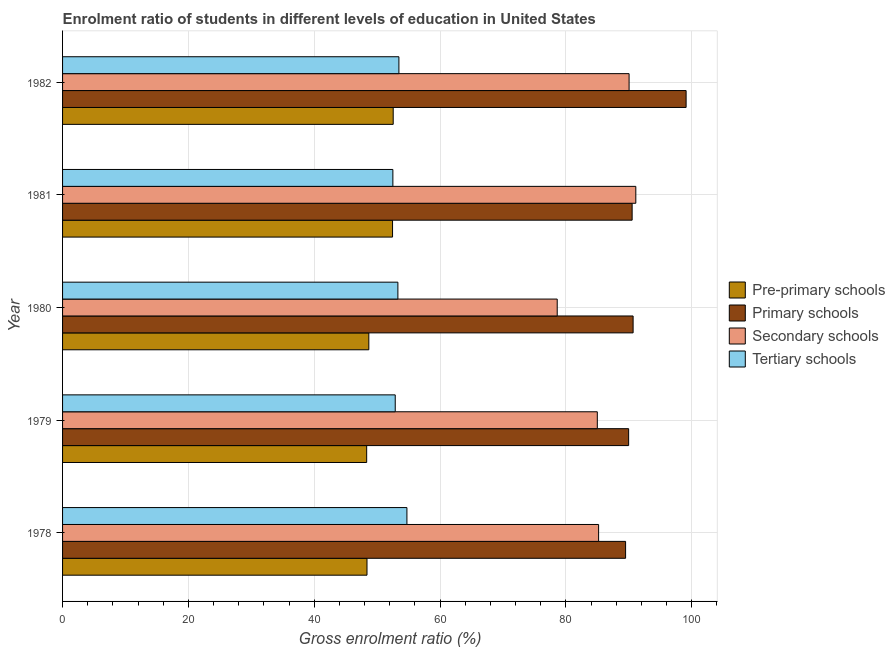How many different coloured bars are there?
Your response must be concise. 4. How many bars are there on the 3rd tick from the top?
Your answer should be very brief. 4. How many bars are there on the 4th tick from the bottom?
Your answer should be compact. 4. What is the label of the 4th group of bars from the top?
Keep it short and to the point. 1979. In how many cases, is the number of bars for a given year not equal to the number of legend labels?
Your answer should be compact. 0. What is the gross enrolment ratio in pre-primary schools in 1979?
Ensure brevity in your answer.  48.33. Across all years, what is the maximum gross enrolment ratio in tertiary schools?
Your answer should be compact. 54.73. Across all years, what is the minimum gross enrolment ratio in primary schools?
Give a very brief answer. 89.49. In which year was the gross enrolment ratio in primary schools minimum?
Your response must be concise. 1978. What is the total gross enrolment ratio in tertiary schools in the graph?
Ensure brevity in your answer.  266.86. What is the difference between the gross enrolment ratio in primary schools in 1978 and that in 1980?
Give a very brief answer. -1.19. What is the difference between the gross enrolment ratio in tertiary schools in 1982 and the gross enrolment ratio in primary schools in 1978?
Your answer should be compact. -36.03. What is the average gross enrolment ratio in pre-primary schools per year?
Give a very brief answer. 50.08. In the year 1978, what is the difference between the gross enrolment ratio in pre-primary schools and gross enrolment ratio in primary schools?
Your answer should be very brief. -41.1. What is the ratio of the gross enrolment ratio in secondary schools in 1978 to that in 1981?
Provide a short and direct response. 0.94. Is the gross enrolment ratio in tertiary schools in 1978 less than that in 1982?
Keep it short and to the point. No. What is the difference between the highest and the second highest gross enrolment ratio in primary schools?
Offer a very short reply. 8.42. What is the difference between the highest and the lowest gross enrolment ratio in tertiary schools?
Ensure brevity in your answer.  2.23. Is the sum of the gross enrolment ratio in tertiary schools in 1978 and 1982 greater than the maximum gross enrolment ratio in secondary schools across all years?
Your answer should be compact. Yes. Is it the case that in every year, the sum of the gross enrolment ratio in pre-primary schools and gross enrolment ratio in primary schools is greater than the sum of gross enrolment ratio in secondary schools and gross enrolment ratio in tertiary schools?
Provide a succinct answer. No. What does the 2nd bar from the top in 1980 represents?
Keep it short and to the point. Secondary schools. What does the 2nd bar from the bottom in 1979 represents?
Offer a very short reply. Primary schools. How many bars are there?
Your answer should be compact. 20. Are all the bars in the graph horizontal?
Give a very brief answer. Yes. How many years are there in the graph?
Your answer should be compact. 5. Are the values on the major ticks of X-axis written in scientific E-notation?
Provide a short and direct response. No. Does the graph contain any zero values?
Your response must be concise. No. Does the graph contain grids?
Provide a succinct answer. Yes. Where does the legend appear in the graph?
Ensure brevity in your answer.  Center right. How many legend labels are there?
Offer a very short reply. 4. How are the legend labels stacked?
Make the answer very short. Vertical. What is the title of the graph?
Your answer should be compact. Enrolment ratio of students in different levels of education in United States. Does "Compensation of employees" appear as one of the legend labels in the graph?
Provide a short and direct response. No. What is the Gross enrolment ratio (%) of Pre-primary schools in 1978?
Offer a very short reply. 48.39. What is the Gross enrolment ratio (%) in Primary schools in 1978?
Your answer should be compact. 89.49. What is the Gross enrolment ratio (%) of Secondary schools in 1978?
Give a very brief answer. 85.2. What is the Gross enrolment ratio (%) of Tertiary schools in 1978?
Make the answer very short. 54.73. What is the Gross enrolment ratio (%) of Pre-primary schools in 1979?
Provide a short and direct response. 48.33. What is the Gross enrolment ratio (%) of Primary schools in 1979?
Give a very brief answer. 89.97. What is the Gross enrolment ratio (%) of Secondary schools in 1979?
Ensure brevity in your answer.  84.99. What is the Gross enrolment ratio (%) of Tertiary schools in 1979?
Provide a short and direct response. 52.87. What is the Gross enrolment ratio (%) in Pre-primary schools in 1980?
Ensure brevity in your answer.  48.68. What is the Gross enrolment ratio (%) of Primary schools in 1980?
Make the answer very short. 90.68. What is the Gross enrolment ratio (%) in Secondary schools in 1980?
Provide a succinct answer. 78.62. What is the Gross enrolment ratio (%) of Tertiary schools in 1980?
Your answer should be compact. 53.3. What is the Gross enrolment ratio (%) of Pre-primary schools in 1981?
Make the answer very short. 52.45. What is the Gross enrolment ratio (%) of Primary schools in 1981?
Your response must be concise. 90.53. What is the Gross enrolment ratio (%) in Secondary schools in 1981?
Make the answer very short. 91.11. What is the Gross enrolment ratio (%) in Tertiary schools in 1981?
Provide a succinct answer. 52.5. What is the Gross enrolment ratio (%) in Pre-primary schools in 1982?
Offer a terse response. 52.55. What is the Gross enrolment ratio (%) in Primary schools in 1982?
Give a very brief answer. 99.11. What is the Gross enrolment ratio (%) in Secondary schools in 1982?
Provide a succinct answer. 90.04. What is the Gross enrolment ratio (%) in Tertiary schools in 1982?
Make the answer very short. 53.46. Across all years, what is the maximum Gross enrolment ratio (%) of Pre-primary schools?
Keep it short and to the point. 52.55. Across all years, what is the maximum Gross enrolment ratio (%) in Primary schools?
Give a very brief answer. 99.11. Across all years, what is the maximum Gross enrolment ratio (%) of Secondary schools?
Your answer should be compact. 91.11. Across all years, what is the maximum Gross enrolment ratio (%) of Tertiary schools?
Ensure brevity in your answer.  54.73. Across all years, what is the minimum Gross enrolment ratio (%) in Pre-primary schools?
Your response must be concise. 48.33. Across all years, what is the minimum Gross enrolment ratio (%) in Primary schools?
Keep it short and to the point. 89.49. Across all years, what is the minimum Gross enrolment ratio (%) in Secondary schools?
Your answer should be compact. 78.62. Across all years, what is the minimum Gross enrolment ratio (%) of Tertiary schools?
Your response must be concise. 52.5. What is the total Gross enrolment ratio (%) in Pre-primary schools in the graph?
Your response must be concise. 250.39. What is the total Gross enrolment ratio (%) of Primary schools in the graph?
Keep it short and to the point. 459.77. What is the total Gross enrolment ratio (%) of Secondary schools in the graph?
Your answer should be very brief. 429.96. What is the total Gross enrolment ratio (%) in Tertiary schools in the graph?
Keep it short and to the point. 266.86. What is the difference between the Gross enrolment ratio (%) of Pre-primary schools in 1978 and that in 1979?
Ensure brevity in your answer.  0.05. What is the difference between the Gross enrolment ratio (%) in Primary schools in 1978 and that in 1979?
Your answer should be compact. -0.48. What is the difference between the Gross enrolment ratio (%) of Secondary schools in 1978 and that in 1979?
Your response must be concise. 0.21. What is the difference between the Gross enrolment ratio (%) of Tertiary schools in 1978 and that in 1979?
Your answer should be very brief. 1.86. What is the difference between the Gross enrolment ratio (%) of Pre-primary schools in 1978 and that in 1980?
Give a very brief answer. -0.29. What is the difference between the Gross enrolment ratio (%) of Primary schools in 1978 and that in 1980?
Ensure brevity in your answer.  -1.19. What is the difference between the Gross enrolment ratio (%) of Secondary schools in 1978 and that in 1980?
Your response must be concise. 6.58. What is the difference between the Gross enrolment ratio (%) in Tertiary schools in 1978 and that in 1980?
Your response must be concise. 1.43. What is the difference between the Gross enrolment ratio (%) of Pre-primary schools in 1978 and that in 1981?
Give a very brief answer. -4.06. What is the difference between the Gross enrolment ratio (%) in Primary schools in 1978 and that in 1981?
Make the answer very short. -1.04. What is the difference between the Gross enrolment ratio (%) in Secondary schools in 1978 and that in 1981?
Make the answer very short. -5.91. What is the difference between the Gross enrolment ratio (%) in Tertiary schools in 1978 and that in 1981?
Make the answer very short. 2.23. What is the difference between the Gross enrolment ratio (%) in Pre-primary schools in 1978 and that in 1982?
Your answer should be very brief. -4.16. What is the difference between the Gross enrolment ratio (%) of Primary schools in 1978 and that in 1982?
Provide a short and direct response. -9.62. What is the difference between the Gross enrolment ratio (%) of Secondary schools in 1978 and that in 1982?
Give a very brief answer. -4.84. What is the difference between the Gross enrolment ratio (%) in Tertiary schools in 1978 and that in 1982?
Offer a very short reply. 1.27. What is the difference between the Gross enrolment ratio (%) of Pre-primary schools in 1979 and that in 1980?
Offer a terse response. -0.34. What is the difference between the Gross enrolment ratio (%) in Primary schools in 1979 and that in 1980?
Give a very brief answer. -0.71. What is the difference between the Gross enrolment ratio (%) in Secondary schools in 1979 and that in 1980?
Offer a terse response. 6.37. What is the difference between the Gross enrolment ratio (%) in Tertiary schools in 1979 and that in 1980?
Ensure brevity in your answer.  -0.42. What is the difference between the Gross enrolment ratio (%) in Pre-primary schools in 1979 and that in 1981?
Keep it short and to the point. -4.11. What is the difference between the Gross enrolment ratio (%) of Primary schools in 1979 and that in 1981?
Offer a terse response. -0.56. What is the difference between the Gross enrolment ratio (%) of Secondary schools in 1979 and that in 1981?
Provide a short and direct response. -6.12. What is the difference between the Gross enrolment ratio (%) of Tertiary schools in 1979 and that in 1981?
Your answer should be compact. 0.38. What is the difference between the Gross enrolment ratio (%) of Pre-primary schools in 1979 and that in 1982?
Keep it short and to the point. -4.22. What is the difference between the Gross enrolment ratio (%) of Primary schools in 1979 and that in 1982?
Give a very brief answer. -9.13. What is the difference between the Gross enrolment ratio (%) of Secondary schools in 1979 and that in 1982?
Your answer should be very brief. -5.05. What is the difference between the Gross enrolment ratio (%) in Tertiary schools in 1979 and that in 1982?
Make the answer very short. -0.58. What is the difference between the Gross enrolment ratio (%) in Pre-primary schools in 1980 and that in 1981?
Provide a short and direct response. -3.77. What is the difference between the Gross enrolment ratio (%) of Primary schools in 1980 and that in 1981?
Offer a very short reply. 0.16. What is the difference between the Gross enrolment ratio (%) of Secondary schools in 1980 and that in 1981?
Your answer should be very brief. -12.49. What is the difference between the Gross enrolment ratio (%) of Tertiary schools in 1980 and that in 1981?
Your answer should be compact. 0.8. What is the difference between the Gross enrolment ratio (%) in Pre-primary schools in 1980 and that in 1982?
Keep it short and to the point. -3.87. What is the difference between the Gross enrolment ratio (%) of Primary schools in 1980 and that in 1982?
Your response must be concise. -8.42. What is the difference between the Gross enrolment ratio (%) in Secondary schools in 1980 and that in 1982?
Your response must be concise. -11.42. What is the difference between the Gross enrolment ratio (%) of Tertiary schools in 1980 and that in 1982?
Keep it short and to the point. -0.16. What is the difference between the Gross enrolment ratio (%) in Pre-primary schools in 1981 and that in 1982?
Your response must be concise. -0.1. What is the difference between the Gross enrolment ratio (%) of Primary schools in 1981 and that in 1982?
Provide a succinct answer. -8.58. What is the difference between the Gross enrolment ratio (%) in Secondary schools in 1981 and that in 1982?
Make the answer very short. 1.07. What is the difference between the Gross enrolment ratio (%) in Tertiary schools in 1981 and that in 1982?
Provide a short and direct response. -0.96. What is the difference between the Gross enrolment ratio (%) in Pre-primary schools in 1978 and the Gross enrolment ratio (%) in Primary schools in 1979?
Your answer should be very brief. -41.58. What is the difference between the Gross enrolment ratio (%) of Pre-primary schools in 1978 and the Gross enrolment ratio (%) of Secondary schools in 1979?
Your answer should be compact. -36.6. What is the difference between the Gross enrolment ratio (%) of Pre-primary schools in 1978 and the Gross enrolment ratio (%) of Tertiary schools in 1979?
Your answer should be very brief. -4.49. What is the difference between the Gross enrolment ratio (%) in Primary schools in 1978 and the Gross enrolment ratio (%) in Secondary schools in 1979?
Give a very brief answer. 4.5. What is the difference between the Gross enrolment ratio (%) of Primary schools in 1978 and the Gross enrolment ratio (%) of Tertiary schools in 1979?
Offer a terse response. 36.61. What is the difference between the Gross enrolment ratio (%) of Secondary schools in 1978 and the Gross enrolment ratio (%) of Tertiary schools in 1979?
Your response must be concise. 32.32. What is the difference between the Gross enrolment ratio (%) of Pre-primary schools in 1978 and the Gross enrolment ratio (%) of Primary schools in 1980?
Keep it short and to the point. -42.3. What is the difference between the Gross enrolment ratio (%) in Pre-primary schools in 1978 and the Gross enrolment ratio (%) in Secondary schools in 1980?
Offer a terse response. -30.23. What is the difference between the Gross enrolment ratio (%) of Pre-primary schools in 1978 and the Gross enrolment ratio (%) of Tertiary schools in 1980?
Ensure brevity in your answer.  -4.91. What is the difference between the Gross enrolment ratio (%) of Primary schools in 1978 and the Gross enrolment ratio (%) of Secondary schools in 1980?
Offer a terse response. 10.87. What is the difference between the Gross enrolment ratio (%) in Primary schools in 1978 and the Gross enrolment ratio (%) in Tertiary schools in 1980?
Your answer should be very brief. 36.19. What is the difference between the Gross enrolment ratio (%) in Secondary schools in 1978 and the Gross enrolment ratio (%) in Tertiary schools in 1980?
Your answer should be very brief. 31.9. What is the difference between the Gross enrolment ratio (%) in Pre-primary schools in 1978 and the Gross enrolment ratio (%) in Primary schools in 1981?
Your answer should be compact. -42.14. What is the difference between the Gross enrolment ratio (%) in Pre-primary schools in 1978 and the Gross enrolment ratio (%) in Secondary schools in 1981?
Your response must be concise. -42.73. What is the difference between the Gross enrolment ratio (%) in Pre-primary schools in 1978 and the Gross enrolment ratio (%) in Tertiary schools in 1981?
Your response must be concise. -4.11. What is the difference between the Gross enrolment ratio (%) in Primary schools in 1978 and the Gross enrolment ratio (%) in Secondary schools in 1981?
Give a very brief answer. -1.62. What is the difference between the Gross enrolment ratio (%) in Primary schools in 1978 and the Gross enrolment ratio (%) in Tertiary schools in 1981?
Your answer should be compact. 36.99. What is the difference between the Gross enrolment ratio (%) in Secondary schools in 1978 and the Gross enrolment ratio (%) in Tertiary schools in 1981?
Your answer should be very brief. 32.7. What is the difference between the Gross enrolment ratio (%) of Pre-primary schools in 1978 and the Gross enrolment ratio (%) of Primary schools in 1982?
Offer a very short reply. -50.72. What is the difference between the Gross enrolment ratio (%) of Pre-primary schools in 1978 and the Gross enrolment ratio (%) of Secondary schools in 1982?
Provide a short and direct response. -41.66. What is the difference between the Gross enrolment ratio (%) in Pre-primary schools in 1978 and the Gross enrolment ratio (%) in Tertiary schools in 1982?
Your answer should be very brief. -5.07. What is the difference between the Gross enrolment ratio (%) of Primary schools in 1978 and the Gross enrolment ratio (%) of Secondary schools in 1982?
Keep it short and to the point. -0.55. What is the difference between the Gross enrolment ratio (%) of Primary schools in 1978 and the Gross enrolment ratio (%) of Tertiary schools in 1982?
Give a very brief answer. 36.03. What is the difference between the Gross enrolment ratio (%) of Secondary schools in 1978 and the Gross enrolment ratio (%) of Tertiary schools in 1982?
Provide a short and direct response. 31.74. What is the difference between the Gross enrolment ratio (%) of Pre-primary schools in 1979 and the Gross enrolment ratio (%) of Primary schools in 1980?
Offer a terse response. -42.35. What is the difference between the Gross enrolment ratio (%) of Pre-primary schools in 1979 and the Gross enrolment ratio (%) of Secondary schools in 1980?
Provide a short and direct response. -30.29. What is the difference between the Gross enrolment ratio (%) of Pre-primary schools in 1979 and the Gross enrolment ratio (%) of Tertiary schools in 1980?
Your response must be concise. -4.96. What is the difference between the Gross enrolment ratio (%) in Primary schools in 1979 and the Gross enrolment ratio (%) in Secondary schools in 1980?
Make the answer very short. 11.35. What is the difference between the Gross enrolment ratio (%) of Primary schools in 1979 and the Gross enrolment ratio (%) of Tertiary schools in 1980?
Keep it short and to the point. 36.67. What is the difference between the Gross enrolment ratio (%) of Secondary schools in 1979 and the Gross enrolment ratio (%) of Tertiary schools in 1980?
Keep it short and to the point. 31.69. What is the difference between the Gross enrolment ratio (%) of Pre-primary schools in 1979 and the Gross enrolment ratio (%) of Primary schools in 1981?
Your answer should be compact. -42.19. What is the difference between the Gross enrolment ratio (%) of Pre-primary schools in 1979 and the Gross enrolment ratio (%) of Secondary schools in 1981?
Ensure brevity in your answer.  -42.78. What is the difference between the Gross enrolment ratio (%) of Pre-primary schools in 1979 and the Gross enrolment ratio (%) of Tertiary schools in 1981?
Ensure brevity in your answer.  -4.17. What is the difference between the Gross enrolment ratio (%) of Primary schools in 1979 and the Gross enrolment ratio (%) of Secondary schools in 1981?
Provide a short and direct response. -1.14. What is the difference between the Gross enrolment ratio (%) in Primary schools in 1979 and the Gross enrolment ratio (%) in Tertiary schools in 1981?
Make the answer very short. 37.47. What is the difference between the Gross enrolment ratio (%) of Secondary schools in 1979 and the Gross enrolment ratio (%) of Tertiary schools in 1981?
Offer a very short reply. 32.49. What is the difference between the Gross enrolment ratio (%) in Pre-primary schools in 1979 and the Gross enrolment ratio (%) in Primary schools in 1982?
Ensure brevity in your answer.  -50.77. What is the difference between the Gross enrolment ratio (%) of Pre-primary schools in 1979 and the Gross enrolment ratio (%) of Secondary schools in 1982?
Give a very brief answer. -41.71. What is the difference between the Gross enrolment ratio (%) in Pre-primary schools in 1979 and the Gross enrolment ratio (%) in Tertiary schools in 1982?
Your answer should be very brief. -5.12. What is the difference between the Gross enrolment ratio (%) of Primary schools in 1979 and the Gross enrolment ratio (%) of Secondary schools in 1982?
Make the answer very short. -0.07. What is the difference between the Gross enrolment ratio (%) in Primary schools in 1979 and the Gross enrolment ratio (%) in Tertiary schools in 1982?
Give a very brief answer. 36.51. What is the difference between the Gross enrolment ratio (%) of Secondary schools in 1979 and the Gross enrolment ratio (%) of Tertiary schools in 1982?
Offer a very short reply. 31.53. What is the difference between the Gross enrolment ratio (%) of Pre-primary schools in 1980 and the Gross enrolment ratio (%) of Primary schools in 1981?
Provide a succinct answer. -41.85. What is the difference between the Gross enrolment ratio (%) of Pre-primary schools in 1980 and the Gross enrolment ratio (%) of Secondary schools in 1981?
Offer a very short reply. -42.44. What is the difference between the Gross enrolment ratio (%) in Pre-primary schools in 1980 and the Gross enrolment ratio (%) in Tertiary schools in 1981?
Your answer should be very brief. -3.82. What is the difference between the Gross enrolment ratio (%) of Primary schools in 1980 and the Gross enrolment ratio (%) of Secondary schools in 1981?
Your response must be concise. -0.43. What is the difference between the Gross enrolment ratio (%) of Primary schools in 1980 and the Gross enrolment ratio (%) of Tertiary schools in 1981?
Your answer should be compact. 38.18. What is the difference between the Gross enrolment ratio (%) of Secondary schools in 1980 and the Gross enrolment ratio (%) of Tertiary schools in 1981?
Make the answer very short. 26.12. What is the difference between the Gross enrolment ratio (%) of Pre-primary schools in 1980 and the Gross enrolment ratio (%) of Primary schools in 1982?
Make the answer very short. -50.43. What is the difference between the Gross enrolment ratio (%) in Pre-primary schools in 1980 and the Gross enrolment ratio (%) in Secondary schools in 1982?
Provide a succinct answer. -41.37. What is the difference between the Gross enrolment ratio (%) in Pre-primary schools in 1980 and the Gross enrolment ratio (%) in Tertiary schools in 1982?
Offer a terse response. -4.78. What is the difference between the Gross enrolment ratio (%) of Primary schools in 1980 and the Gross enrolment ratio (%) of Secondary schools in 1982?
Provide a short and direct response. 0.64. What is the difference between the Gross enrolment ratio (%) of Primary schools in 1980 and the Gross enrolment ratio (%) of Tertiary schools in 1982?
Offer a very short reply. 37.22. What is the difference between the Gross enrolment ratio (%) of Secondary schools in 1980 and the Gross enrolment ratio (%) of Tertiary schools in 1982?
Your response must be concise. 25.16. What is the difference between the Gross enrolment ratio (%) in Pre-primary schools in 1981 and the Gross enrolment ratio (%) in Primary schools in 1982?
Offer a terse response. -46.66. What is the difference between the Gross enrolment ratio (%) of Pre-primary schools in 1981 and the Gross enrolment ratio (%) of Secondary schools in 1982?
Keep it short and to the point. -37.6. What is the difference between the Gross enrolment ratio (%) of Pre-primary schools in 1981 and the Gross enrolment ratio (%) of Tertiary schools in 1982?
Keep it short and to the point. -1.01. What is the difference between the Gross enrolment ratio (%) of Primary schools in 1981 and the Gross enrolment ratio (%) of Secondary schools in 1982?
Provide a short and direct response. 0.48. What is the difference between the Gross enrolment ratio (%) of Primary schools in 1981 and the Gross enrolment ratio (%) of Tertiary schools in 1982?
Offer a terse response. 37.07. What is the difference between the Gross enrolment ratio (%) in Secondary schools in 1981 and the Gross enrolment ratio (%) in Tertiary schools in 1982?
Make the answer very short. 37.65. What is the average Gross enrolment ratio (%) in Pre-primary schools per year?
Provide a short and direct response. 50.08. What is the average Gross enrolment ratio (%) in Primary schools per year?
Your answer should be very brief. 91.95. What is the average Gross enrolment ratio (%) of Secondary schools per year?
Ensure brevity in your answer.  85.99. What is the average Gross enrolment ratio (%) of Tertiary schools per year?
Provide a succinct answer. 53.37. In the year 1978, what is the difference between the Gross enrolment ratio (%) in Pre-primary schools and Gross enrolment ratio (%) in Primary schools?
Make the answer very short. -41.1. In the year 1978, what is the difference between the Gross enrolment ratio (%) of Pre-primary schools and Gross enrolment ratio (%) of Secondary schools?
Give a very brief answer. -36.81. In the year 1978, what is the difference between the Gross enrolment ratio (%) in Pre-primary schools and Gross enrolment ratio (%) in Tertiary schools?
Offer a very short reply. -6.34. In the year 1978, what is the difference between the Gross enrolment ratio (%) in Primary schools and Gross enrolment ratio (%) in Secondary schools?
Ensure brevity in your answer.  4.29. In the year 1978, what is the difference between the Gross enrolment ratio (%) of Primary schools and Gross enrolment ratio (%) of Tertiary schools?
Provide a short and direct response. 34.76. In the year 1978, what is the difference between the Gross enrolment ratio (%) in Secondary schools and Gross enrolment ratio (%) in Tertiary schools?
Your answer should be compact. 30.47. In the year 1979, what is the difference between the Gross enrolment ratio (%) in Pre-primary schools and Gross enrolment ratio (%) in Primary schools?
Give a very brief answer. -41.64. In the year 1979, what is the difference between the Gross enrolment ratio (%) in Pre-primary schools and Gross enrolment ratio (%) in Secondary schools?
Provide a short and direct response. -36.66. In the year 1979, what is the difference between the Gross enrolment ratio (%) in Pre-primary schools and Gross enrolment ratio (%) in Tertiary schools?
Your response must be concise. -4.54. In the year 1979, what is the difference between the Gross enrolment ratio (%) in Primary schools and Gross enrolment ratio (%) in Secondary schools?
Offer a terse response. 4.98. In the year 1979, what is the difference between the Gross enrolment ratio (%) of Primary schools and Gross enrolment ratio (%) of Tertiary schools?
Make the answer very short. 37.1. In the year 1979, what is the difference between the Gross enrolment ratio (%) of Secondary schools and Gross enrolment ratio (%) of Tertiary schools?
Make the answer very short. 32.12. In the year 1980, what is the difference between the Gross enrolment ratio (%) in Pre-primary schools and Gross enrolment ratio (%) in Primary schools?
Make the answer very short. -42.01. In the year 1980, what is the difference between the Gross enrolment ratio (%) of Pre-primary schools and Gross enrolment ratio (%) of Secondary schools?
Offer a terse response. -29.94. In the year 1980, what is the difference between the Gross enrolment ratio (%) of Pre-primary schools and Gross enrolment ratio (%) of Tertiary schools?
Provide a succinct answer. -4.62. In the year 1980, what is the difference between the Gross enrolment ratio (%) of Primary schools and Gross enrolment ratio (%) of Secondary schools?
Give a very brief answer. 12.06. In the year 1980, what is the difference between the Gross enrolment ratio (%) in Primary schools and Gross enrolment ratio (%) in Tertiary schools?
Provide a short and direct response. 37.39. In the year 1980, what is the difference between the Gross enrolment ratio (%) in Secondary schools and Gross enrolment ratio (%) in Tertiary schools?
Keep it short and to the point. 25.32. In the year 1981, what is the difference between the Gross enrolment ratio (%) of Pre-primary schools and Gross enrolment ratio (%) of Primary schools?
Offer a very short reply. -38.08. In the year 1981, what is the difference between the Gross enrolment ratio (%) in Pre-primary schools and Gross enrolment ratio (%) in Secondary schools?
Your answer should be compact. -38.67. In the year 1981, what is the difference between the Gross enrolment ratio (%) of Pre-primary schools and Gross enrolment ratio (%) of Tertiary schools?
Offer a terse response. -0.05. In the year 1981, what is the difference between the Gross enrolment ratio (%) of Primary schools and Gross enrolment ratio (%) of Secondary schools?
Keep it short and to the point. -0.59. In the year 1981, what is the difference between the Gross enrolment ratio (%) in Primary schools and Gross enrolment ratio (%) in Tertiary schools?
Provide a succinct answer. 38.03. In the year 1981, what is the difference between the Gross enrolment ratio (%) in Secondary schools and Gross enrolment ratio (%) in Tertiary schools?
Your answer should be compact. 38.61. In the year 1982, what is the difference between the Gross enrolment ratio (%) in Pre-primary schools and Gross enrolment ratio (%) in Primary schools?
Your answer should be very brief. -46.55. In the year 1982, what is the difference between the Gross enrolment ratio (%) in Pre-primary schools and Gross enrolment ratio (%) in Secondary schools?
Make the answer very short. -37.49. In the year 1982, what is the difference between the Gross enrolment ratio (%) of Pre-primary schools and Gross enrolment ratio (%) of Tertiary schools?
Your answer should be compact. -0.91. In the year 1982, what is the difference between the Gross enrolment ratio (%) of Primary schools and Gross enrolment ratio (%) of Secondary schools?
Ensure brevity in your answer.  9.06. In the year 1982, what is the difference between the Gross enrolment ratio (%) of Primary schools and Gross enrolment ratio (%) of Tertiary schools?
Make the answer very short. 45.65. In the year 1982, what is the difference between the Gross enrolment ratio (%) in Secondary schools and Gross enrolment ratio (%) in Tertiary schools?
Your answer should be very brief. 36.58. What is the ratio of the Gross enrolment ratio (%) in Pre-primary schools in 1978 to that in 1979?
Your response must be concise. 1. What is the ratio of the Gross enrolment ratio (%) of Secondary schools in 1978 to that in 1979?
Keep it short and to the point. 1. What is the ratio of the Gross enrolment ratio (%) in Tertiary schools in 1978 to that in 1979?
Ensure brevity in your answer.  1.04. What is the ratio of the Gross enrolment ratio (%) of Primary schools in 1978 to that in 1980?
Make the answer very short. 0.99. What is the ratio of the Gross enrolment ratio (%) in Secondary schools in 1978 to that in 1980?
Provide a succinct answer. 1.08. What is the ratio of the Gross enrolment ratio (%) of Tertiary schools in 1978 to that in 1980?
Provide a succinct answer. 1.03. What is the ratio of the Gross enrolment ratio (%) of Pre-primary schools in 1978 to that in 1981?
Your answer should be very brief. 0.92. What is the ratio of the Gross enrolment ratio (%) of Secondary schools in 1978 to that in 1981?
Offer a very short reply. 0.94. What is the ratio of the Gross enrolment ratio (%) of Tertiary schools in 1978 to that in 1981?
Your answer should be compact. 1.04. What is the ratio of the Gross enrolment ratio (%) of Pre-primary schools in 1978 to that in 1982?
Your response must be concise. 0.92. What is the ratio of the Gross enrolment ratio (%) in Primary schools in 1978 to that in 1982?
Make the answer very short. 0.9. What is the ratio of the Gross enrolment ratio (%) in Secondary schools in 1978 to that in 1982?
Offer a terse response. 0.95. What is the ratio of the Gross enrolment ratio (%) in Tertiary schools in 1978 to that in 1982?
Make the answer very short. 1.02. What is the ratio of the Gross enrolment ratio (%) of Pre-primary schools in 1979 to that in 1980?
Provide a succinct answer. 0.99. What is the ratio of the Gross enrolment ratio (%) in Secondary schools in 1979 to that in 1980?
Your answer should be compact. 1.08. What is the ratio of the Gross enrolment ratio (%) in Tertiary schools in 1979 to that in 1980?
Your answer should be compact. 0.99. What is the ratio of the Gross enrolment ratio (%) in Pre-primary schools in 1979 to that in 1981?
Your answer should be very brief. 0.92. What is the ratio of the Gross enrolment ratio (%) of Secondary schools in 1979 to that in 1981?
Give a very brief answer. 0.93. What is the ratio of the Gross enrolment ratio (%) in Tertiary schools in 1979 to that in 1981?
Offer a very short reply. 1.01. What is the ratio of the Gross enrolment ratio (%) in Pre-primary schools in 1979 to that in 1982?
Ensure brevity in your answer.  0.92. What is the ratio of the Gross enrolment ratio (%) of Primary schools in 1979 to that in 1982?
Offer a very short reply. 0.91. What is the ratio of the Gross enrolment ratio (%) in Secondary schools in 1979 to that in 1982?
Your response must be concise. 0.94. What is the ratio of the Gross enrolment ratio (%) in Tertiary schools in 1979 to that in 1982?
Make the answer very short. 0.99. What is the ratio of the Gross enrolment ratio (%) in Pre-primary schools in 1980 to that in 1981?
Your answer should be very brief. 0.93. What is the ratio of the Gross enrolment ratio (%) in Primary schools in 1980 to that in 1981?
Ensure brevity in your answer.  1. What is the ratio of the Gross enrolment ratio (%) in Secondary schools in 1980 to that in 1981?
Ensure brevity in your answer.  0.86. What is the ratio of the Gross enrolment ratio (%) in Tertiary schools in 1980 to that in 1981?
Your answer should be compact. 1.02. What is the ratio of the Gross enrolment ratio (%) in Pre-primary schools in 1980 to that in 1982?
Your response must be concise. 0.93. What is the ratio of the Gross enrolment ratio (%) of Primary schools in 1980 to that in 1982?
Your answer should be compact. 0.92. What is the ratio of the Gross enrolment ratio (%) of Secondary schools in 1980 to that in 1982?
Provide a short and direct response. 0.87. What is the ratio of the Gross enrolment ratio (%) in Primary schools in 1981 to that in 1982?
Make the answer very short. 0.91. What is the ratio of the Gross enrolment ratio (%) of Secondary schools in 1981 to that in 1982?
Make the answer very short. 1.01. What is the ratio of the Gross enrolment ratio (%) of Tertiary schools in 1981 to that in 1982?
Offer a terse response. 0.98. What is the difference between the highest and the second highest Gross enrolment ratio (%) of Pre-primary schools?
Provide a succinct answer. 0.1. What is the difference between the highest and the second highest Gross enrolment ratio (%) of Primary schools?
Ensure brevity in your answer.  8.42. What is the difference between the highest and the second highest Gross enrolment ratio (%) in Secondary schools?
Give a very brief answer. 1.07. What is the difference between the highest and the second highest Gross enrolment ratio (%) in Tertiary schools?
Your answer should be very brief. 1.27. What is the difference between the highest and the lowest Gross enrolment ratio (%) in Pre-primary schools?
Offer a very short reply. 4.22. What is the difference between the highest and the lowest Gross enrolment ratio (%) of Primary schools?
Your answer should be compact. 9.62. What is the difference between the highest and the lowest Gross enrolment ratio (%) in Secondary schools?
Make the answer very short. 12.49. What is the difference between the highest and the lowest Gross enrolment ratio (%) of Tertiary schools?
Provide a short and direct response. 2.23. 